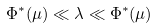Convert formula to latex. <formula><loc_0><loc_0><loc_500><loc_500>\Phi ^ { * } ( \mu ) \ll \lambda \ll \Phi ^ { * } ( \mu )</formula> 